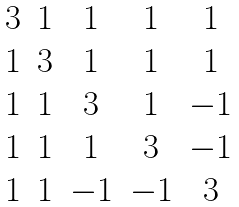<formula> <loc_0><loc_0><loc_500><loc_500>\begin{matrix} 3 & 1 & 1 & 1 & 1 \\ 1 & 3 & 1 & 1 & 1 \\ 1 & 1 & 3 & 1 & - 1 \\ 1 & 1 & 1 & 3 & - 1 \\ 1 & 1 & - 1 & - 1 & 3 \end{matrix}</formula> 